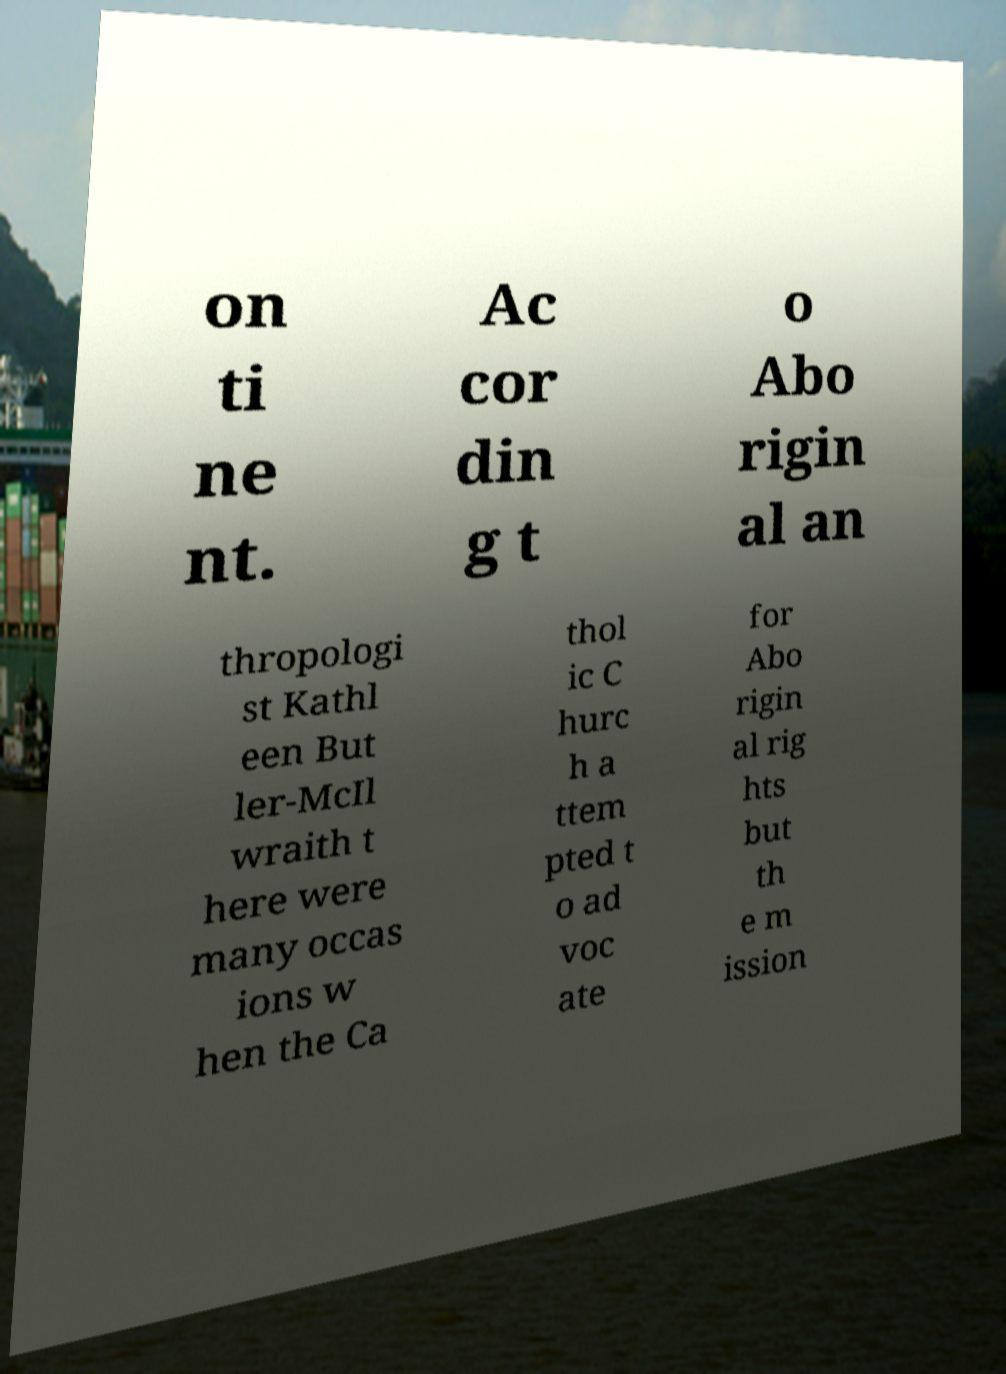Please identify and transcribe the text found in this image. on ti ne nt. Ac cor din g t o Abo rigin al an thropologi st Kathl een But ler-McIl wraith t here were many occas ions w hen the Ca thol ic C hurc h a ttem pted t o ad voc ate for Abo rigin al rig hts but th e m ission 